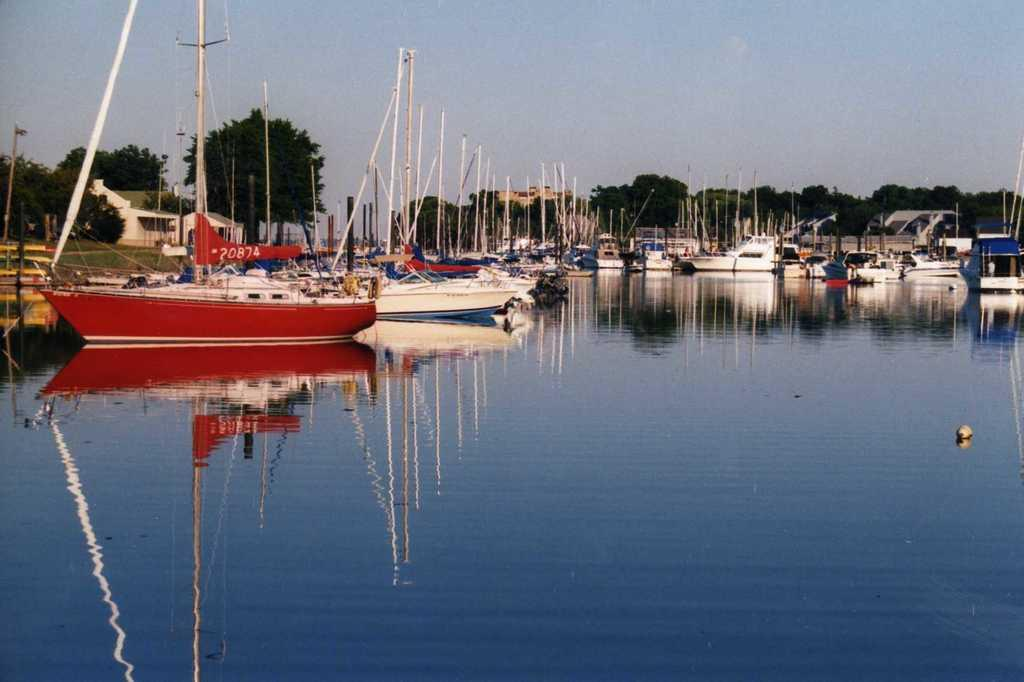What is located above the water in the image? There are ships above the water in the image. What objects can be seen in the image besides the ships? There are poles, a banner, trees, houses, grass, and the sky visible in the image. Can you describe the background of the image? The background of the image includes trees, houses, grass, and the sky. Where is the toad sitting on the glass seat in the image? There is no toad or glass seat present in the image. 